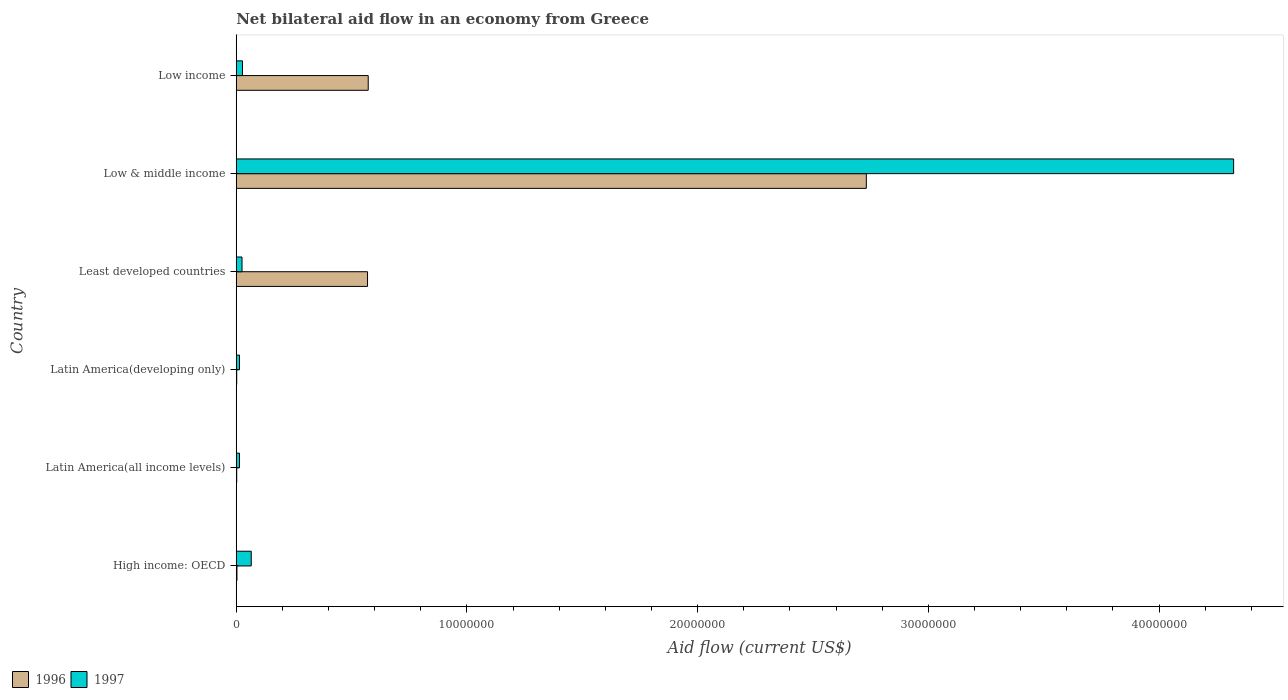How many different coloured bars are there?
Offer a terse response. 2. Are the number of bars per tick equal to the number of legend labels?
Offer a very short reply. Yes. How many bars are there on the 5th tick from the top?
Provide a short and direct response. 2. What is the label of the 4th group of bars from the top?
Give a very brief answer. Latin America(developing only). What is the net bilateral aid flow in 1996 in Low income?
Ensure brevity in your answer.  5.72e+06. Across all countries, what is the maximum net bilateral aid flow in 1997?
Offer a very short reply. 4.32e+07. In which country was the net bilateral aid flow in 1997 maximum?
Ensure brevity in your answer.  Low & middle income. In which country was the net bilateral aid flow in 1997 minimum?
Make the answer very short. Latin America(all income levels). What is the total net bilateral aid flow in 1997 in the graph?
Ensure brevity in your answer.  4.47e+07. What is the difference between the net bilateral aid flow in 1996 in High income: OECD and that in Low income?
Offer a terse response. -5.69e+06. What is the difference between the net bilateral aid flow in 1997 in Latin America(all income levels) and the net bilateral aid flow in 1996 in Low & middle income?
Provide a short and direct response. -2.72e+07. What is the average net bilateral aid flow in 1997 per country?
Your answer should be very brief. 7.45e+06. What is the difference between the net bilateral aid flow in 1997 and net bilateral aid flow in 1996 in Least developed countries?
Your response must be concise. -5.44e+06. In how many countries, is the net bilateral aid flow in 1996 greater than 20000000 US$?
Offer a terse response. 1. What is the ratio of the net bilateral aid flow in 1996 in Latin America(all income levels) to that in Low & middle income?
Give a very brief answer. 0. Is the difference between the net bilateral aid flow in 1997 in Latin America(all income levels) and Least developed countries greater than the difference between the net bilateral aid flow in 1996 in Latin America(all income levels) and Least developed countries?
Make the answer very short. Yes. What is the difference between the highest and the second highest net bilateral aid flow in 1997?
Keep it short and to the point. 4.26e+07. What is the difference between the highest and the lowest net bilateral aid flow in 1997?
Keep it short and to the point. 4.31e+07. Is the sum of the net bilateral aid flow in 1996 in Least developed countries and Low income greater than the maximum net bilateral aid flow in 1997 across all countries?
Your response must be concise. No. What does the 2nd bar from the top in Low & middle income represents?
Your answer should be very brief. 1996. What does the 2nd bar from the bottom in Least developed countries represents?
Keep it short and to the point. 1997. How many bars are there?
Ensure brevity in your answer.  12. Are all the bars in the graph horizontal?
Your response must be concise. Yes. How many countries are there in the graph?
Provide a succinct answer. 6. Are the values on the major ticks of X-axis written in scientific E-notation?
Your answer should be very brief. No. Does the graph contain grids?
Offer a terse response. No. How many legend labels are there?
Keep it short and to the point. 2. How are the legend labels stacked?
Give a very brief answer. Horizontal. What is the title of the graph?
Your answer should be compact. Net bilateral aid flow in an economy from Greece. Does "1982" appear as one of the legend labels in the graph?
Ensure brevity in your answer.  No. What is the Aid flow (current US$) of 1997 in High income: OECD?
Ensure brevity in your answer.  6.50e+05. What is the Aid flow (current US$) in 1997 in Latin America(all income levels)?
Ensure brevity in your answer.  1.40e+05. What is the Aid flow (current US$) of 1997 in Latin America(developing only)?
Your response must be concise. 1.40e+05. What is the Aid flow (current US$) of 1996 in Least developed countries?
Your response must be concise. 5.69e+06. What is the Aid flow (current US$) in 1996 in Low & middle income?
Your answer should be compact. 2.73e+07. What is the Aid flow (current US$) in 1997 in Low & middle income?
Offer a terse response. 4.32e+07. What is the Aid flow (current US$) in 1996 in Low income?
Your answer should be compact. 5.72e+06. What is the Aid flow (current US$) in 1997 in Low income?
Your answer should be compact. 2.70e+05. Across all countries, what is the maximum Aid flow (current US$) of 1996?
Give a very brief answer. 2.73e+07. Across all countries, what is the maximum Aid flow (current US$) of 1997?
Provide a short and direct response. 4.32e+07. Across all countries, what is the minimum Aid flow (current US$) in 1996?
Keep it short and to the point. 2.00e+04. What is the total Aid flow (current US$) in 1996 in the graph?
Offer a very short reply. 3.88e+07. What is the total Aid flow (current US$) of 1997 in the graph?
Your response must be concise. 4.47e+07. What is the difference between the Aid flow (current US$) in 1997 in High income: OECD and that in Latin America(all income levels)?
Ensure brevity in your answer.  5.10e+05. What is the difference between the Aid flow (current US$) in 1997 in High income: OECD and that in Latin America(developing only)?
Offer a terse response. 5.10e+05. What is the difference between the Aid flow (current US$) of 1996 in High income: OECD and that in Least developed countries?
Provide a short and direct response. -5.66e+06. What is the difference between the Aid flow (current US$) of 1996 in High income: OECD and that in Low & middle income?
Your answer should be compact. -2.73e+07. What is the difference between the Aid flow (current US$) in 1997 in High income: OECD and that in Low & middle income?
Your answer should be very brief. -4.26e+07. What is the difference between the Aid flow (current US$) in 1996 in High income: OECD and that in Low income?
Offer a very short reply. -5.69e+06. What is the difference between the Aid flow (current US$) in 1996 in Latin America(all income levels) and that in Least developed countries?
Your response must be concise. -5.67e+06. What is the difference between the Aid flow (current US$) of 1996 in Latin America(all income levels) and that in Low & middle income?
Your answer should be compact. -2.73e+07. What is the difference between the Aid flow (current US$) of 1997 in Latin America(all income levels) and that in Low & middle income?
Your response must be concise. -4.31e+07. What is the difference between the Aid flow (current US$) in 1996 in Latin America(all income levels) and that in Low income?
Provide a short and direct response. -5.70e+06. What is the difference between the Aid flow (current US$) in 1996 in Latin America(developing only) and that in Least developed countries?
Offer a terse response. -5.67e+06. What is the difference between the Aid flow (current US$) of 1997 in Latin America(developing only) and that in Least developed countries?
Keep it short and to the point. -1.10e+05. What is the difference between the Aid flow (current US$) in 1996 in Latin America(developing only) and that in Low & middle income?
Provide a succinct answer. -2.73e+07. What is the difference between the Aid flow (current US$) of 1997 in Latin America(developing only) and that in Low & middle income?
Ensure brevity in your answer.  -4.31e+07. What is the difference between the Aid flow (current US$) of 1996 in Latin America(developing only) and that in Low income?
Provide a short and direct response. -5.70e+06. What is the difference between the Aid flow (current US$) of 1996 in Least developed countries and that in Low & middle income?
Your answer should be very brief. -2.16e+07. What is the difference between the Aid flow (current US$) in 1997 in Least developed countries and that in Low & middle income?
Your answer should be very brief. -4.30e+07. What is the difference between the Aid flow (current US$) of 1996 in Low & middle income and that in Low income?
Your answer should be compact. 2.16e+07. What is the difference between the Aid flow (current US$) in 1997 in Low & middle income and that in Low income?
Keep it short and to the point. 4.30e+07. What is the difference between the Aid flow (current US$) of 1996 in High income: OECD and the Aid flow (current US$) of 1997 in Latin America(all income levels)?
Your answer should be very brief. -1.10e+05. What is the difference between the Aid flow (current US$) of 1996 in High income: OECD and the Aid flow (current US$) of 1997 in Latin America(developing only)?
Keep it short and to the point. -1.10e+05. What is the difference between the Aid flow (current US$) of 1996 in High income: OECD and the Aid flow (current US$) of 1997 in Low & middle income?
Make the answer very short. -4.32e+07. What is the difference between the Aid flow (current US$) of 1996 in Latin America(all income levels) and the Aid flow (current US$) of 1997 in Low & middle income?
Offer a terse response. -4.32e+07. What is the difference between the Aid flow (current US$) in 1996 in Latin America(developing only) and the Aid flow (current US$) in 1997 in Least developed countries?
Ensure brevity in your answer.  -2.30e+05. What is the difference between the Aid flow (current US$) in 1996 in Latin America(developing only) and the Aid flow (current US$) in 1997 in Low & middle income?
Offer a very short reply. -4.32e+07. What is the difference between the Aid flow (current US$) of 1996 in Latin America(developing only) and the Aid flow (current US$) of 1997 in Low income?
Your answer should be compact. -2.50e+05. What is the difference between the Aid flow (current US$) in 1996 in Least developed countries and the Aid flow (current US$) in 1997 in Low & middle income?
Provide a succinct answer. -3.75e+07. What is the difference between the Aid flow (current US$) of 1996 in Least developed countries and the Aid flow (current US$) of 1997 in Low income?
Give a very brief answer. 5.42e+06. What is the difference between the Aid flow (current US$) of 1996 in Low & middle income and the Aid flow (current US$) of 1997 in Low income?
Your response must be concise. 2.70e+07. What is the average Aid flow (current US$) of 1996 per country?
Your response must be concise. 6.46e+06. What is the average Aid flow (current US$) of 1997 per country?
Offer a very short reply. 7.45e+06. What is the difference between the Aid flow (current US$) of 1996 and Aid flow (current US$) of 1997 in High income: OECD?
Your answer should be compact. -6.20e+05. What is the difference between the Aid flow (current US$) of 1996 and Aid flow (current US$) of 1997 in Latin America(developing only)?
Give a very brief answer. -1.20e+05. What is the difference between the Aid flow (current US$) of 1996 and Aid flow (current US$) of 1997 in Least developed countries?
Give a very brief answer. 5.44e+06. What is the difference between the Aid flow (current US$) of 1996 and Aid flow (current US$) of 1997 in Low & middle income?
Provide a succinct answer. -1.59e+07. What is the difference between the Aid flow (current US$) in 1996 and Aid flow (current US$) in 1997 in Low income?
Provide a short and direct response. 5.45e+06. What is the ratio of the Aid flow (current US$) of 1996 in High income: OECD to that in Latin America(all income levels)?
Your answer should be very brief. 1.5. What is the ratio of the Aid flow (current US$) in 1997 in High income: OECD to that in Latin America(all income levels)?
Offer a very short reply. 4.64. What is the ratio of the Aid flow (current US$) of 1996 in High income: OECD to that in Latin America(developing only)?
Ensure brevity in your answer.  1.5. What is the ratio of the Aid flow (current US$) in 1997 in High income: OECD to that in Latin America(developing only)?
Your response must be concise. 4.64. What is the ratio of the Aid flow (current US$) in 1996 in High income: OECD to that in Least developed countries?
Give a very brief answer. 0.01. What is the ratio of the Aid flow (current US$) of 1996 in High income: OECD to that in Low & middle income?
Offer a very short reply. 0. What is the ratio of the Aid flow (current US$) of 1997 in High income: OECD to that in Low & middle income?
Offer a terse response. 0.01. What is the ratio of the Aid flow (current US$) in 1996 in High income: OECD to that in Low income?
Your response must be concise. 0.01. What is the ratio of the Aid flow (current US$) in 1997 in High income: OECD to that in Low income?
Provide a short and direct response. 2.41. What is the ratio of the Aid flow (current US$) of 1996 in Latin America(all income levels) to that in Least developed countries?
Your answer should be very brief. 0. What is the ratio of the Aid flow (current US$) in 1997 in Latin America(all income levels) to that in Least developed countries?
Keep it short and to the point. 0.56. What is the ratio of the Aid flow (current US$) of 1996 in Latin America(all income levels) to that in Low & middle income?
Provide a short and direct response. 0. What is the ratio of the Aid flow (current US$) of 1997 in Latin America(all income levels) to that in Low & middle income?
Ensure brevity in your answer.  0. What is the ratio of the Aid flow (current US$) in 1996 in Latin America(all income levels) to that in Low income?
Keep it short and to the point. 0. What is the ratio of the Aid flow (current US$) in 1997 in Latin America(all income levels) to that in Low income?
Provide a short and direct response. 0.52. What is the ratio of the Aid flow (current US$) of 1996 in Latin America(developing only) to that in Least developed countries?
Your answer should be compact. 0. What is the ratio of the Aid flow (current US$) of 1997 in Latin America(developing only) to that in Least developed countries?
Provide a succinct answer. 0.56. What is the ratio of the Aid flow (current US$) in 1996 in Latin America(developing only) to that in Low & middle income?
Your answer should be compact. 0. What is the ratio of the Aid flow (current US$) in 1997 in Latin America(developing only) to that in Low & middle income?
Keep it short and to the point. 0. What is the ratio of the Aid flow (current US$) of 1996 in Latin America(developing only) to that in Low income?
Your answer should be compact. 0. What is the ratio of the Aid flow (current US$) in 1997 in Latin America(developing only) to that in Low income?
Your answer should be very brief. 0.52. What is the ratio of the Aid flow (current US$) of 1996 in Least developed countries to that in Low & middle income?
Offer a terse response. 0.21. What is the ratio of the Aid flow (current US$) in 1997 in Least developed countries to that in Low & middle income?
Keep it short and to the point. 0.01. What is the ratio of the Aid flow (current US$) in 1996 in Least developed countries to that in Low income?
Ensure brevity in your answer.  0.99. What is the ratio of the Aid flow (current US$) in 1997 in Least developed countries to that in Low income?
Your answer should be very brief. 0.93. What is the ratio of the Aid flow (current US$) of 1996 in Low & middle income to that in Low income?
Give a very brief answer. 4.77. What is the ratio of the Aid flow (current US$) in 1997 in Low & middle income to that in Low income?
Your answer should be compact. 160.11. What is the difference between the highest and the second highest Aid flow (current US$) of 1996?
Offer a very short reply. 2.16e+07. What is the difference between the highest and the second highest Aid flow (current US$) in 1997?
Offer a terse response. 4.26e+07. What is the difference between the highest and the lowest Aid flow (current US$) of 1996?
Your answer should be compact. 2.73e+07. What is the difference between the highest and the lowest Aid flow (current US$) in 1997?
Your answer should be very brief. 4.31e+07. 